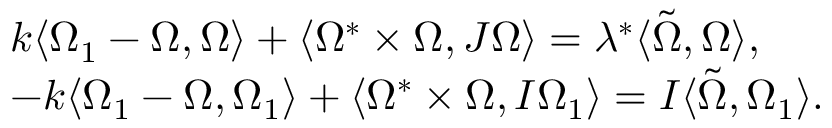<formula> <loc_0><loc_0><loc_500><loc_500>\begin{array} { r l } & { k \langle \Omega _ { 1 } - \Omega , \Omega \rangle + \langle \Omega ^ { * } \times \Omega , J \Omega \rangle = \lambda ^ { * } \langle \tilde { \Omega } , \Omega \rangle , } \\ & { - k \langle \Omega _ { 1 } - \Omega , \Omega _ { 1 } \rangle + \langle \Omega ^ { * } \times \Omega , I \Omega _ { 1 } \rangle = I \langle \tilde { \Omega } , \Omega _ { 1 } \rangle . } \end{array}</formula> 